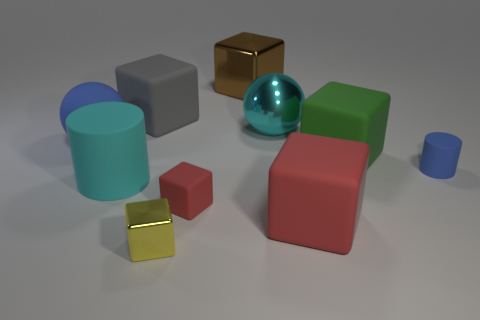What number of cyan metal objects have the same shape as the tiny yellow thing?
Provide a succinct answer. 0. Is the color of the rubber ball the same as the big cylinder?
Ensure brevity in your answer.  No. Are there any other things that are the same shape as the gray matte thing?
Offer a very short reply. Yes. Is there a object of the same color as the tiny rubber cylinder?
Your response must be concise. Yes. Does the big cyan thing in front of the small blue matte thing have the same material as the cylinder on the right side of the brown block?
Your answer should be compact. Yes. What is the color of the large cylinder?
Keep it short and to the point. Cyan. What is the size of the sphere that is to the right of the big cyan thing in front of the rubber thing left of the big cyan rubber cylinder?
Keep it short and to the point. Large. How many other objects are the same size as the blue cylinder?
Offer a very short reply. 2. What number of gray cylinders are made of the same material as the cyan cylinder?
Ensure brevity in your answer.  0. There is a big cyan object that is on the right side of the small yellow block; what is its shape?
Offer a very short reply. Sphere. 